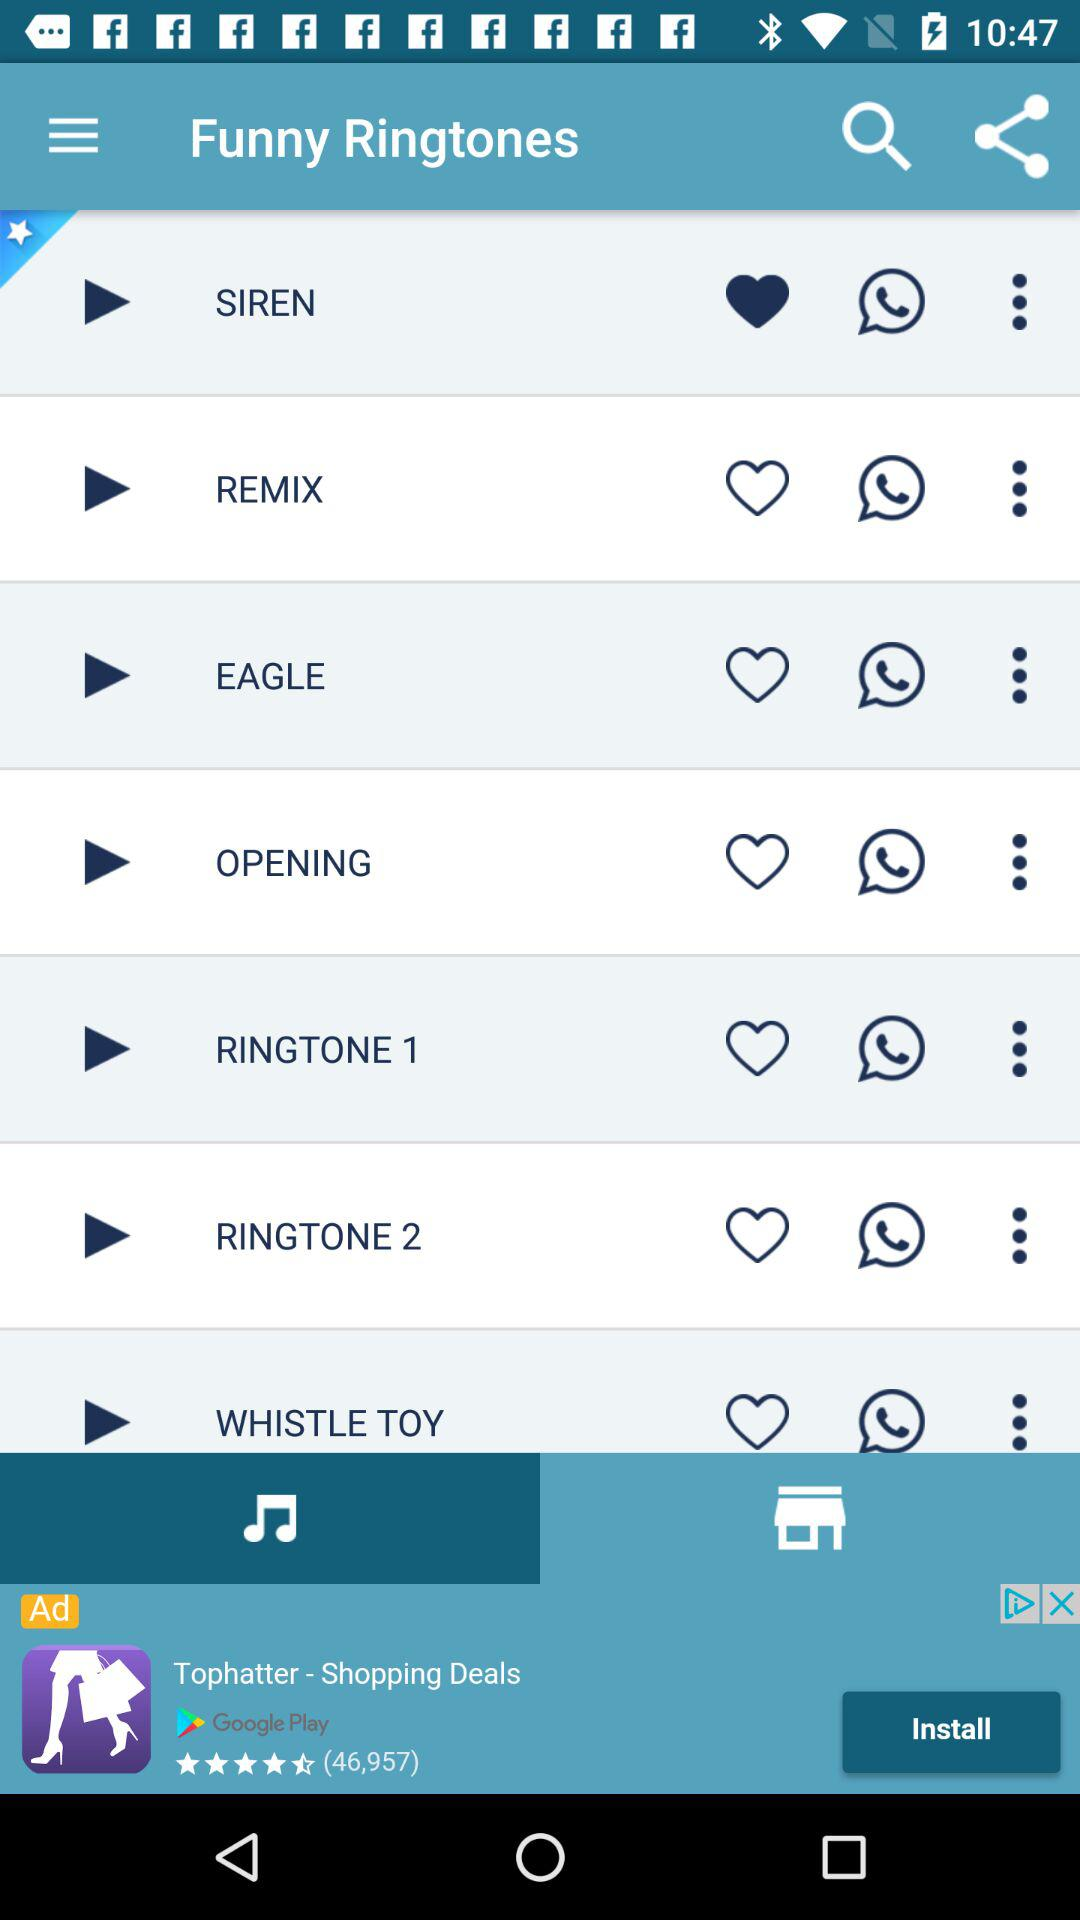How long is the ringtone "SIREN"?
When the provided information is insufficient, respond with <no answer>. <no answer> 